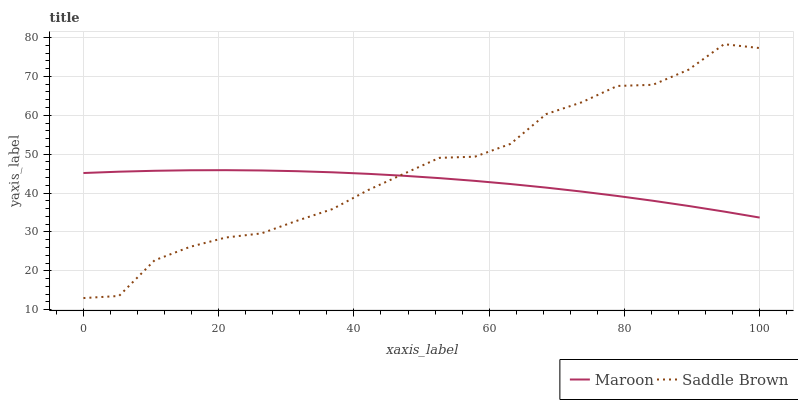Does Maroon have the minimum area under the curve?
Answer yes or no. Yes. Does Saddle Brown have the maximum area under the curve?
Answer yes or no. Yes. Does Maroon have the maximum area under the curve?
Answer yes or no. No. Is Maroon the smoothest?
Answer yes or no. Yes. Is Saddle Brown the roughest?
Answer yes or no. Yes. Is Maroon the roughest?
Answer yes or no. No. Does Maroon have the lowest value?
Answer yes or no. No. Does Maroon have the highest value?
Answer yes or no. No. 